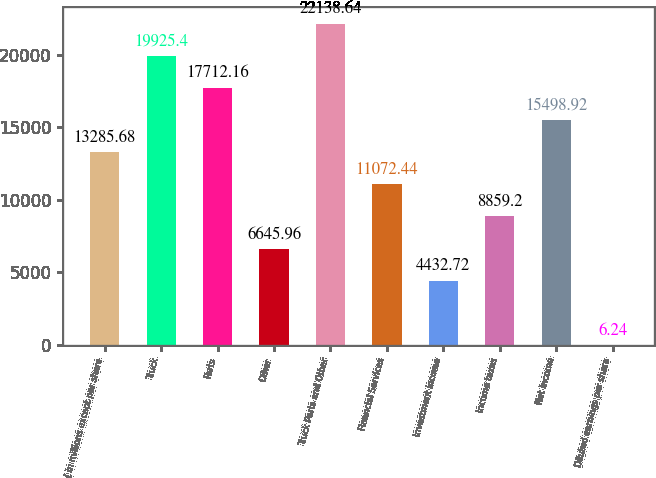<chart> <loc_0><loc_0><loc_500><loc_500><bar_chart><fcel>( in millions except per share<fcel>Truck<fcel>Parts<fcel>Other<fcel>Truck Parts and Other<fcel>Financial Services<fcel>Investment income<fcel>Income taxes<fcel>Net Income<fcel>Diluted earnings per share<nl><fcel>13285.7<fcel>19925.4<fcel>17712.2<fcel>6645.96<fcel>22138.6<fcel>11072.4<fcel>4432.72<fcel>8859.2<fcel>15498.9<fcel>6.24<nl></chart> 